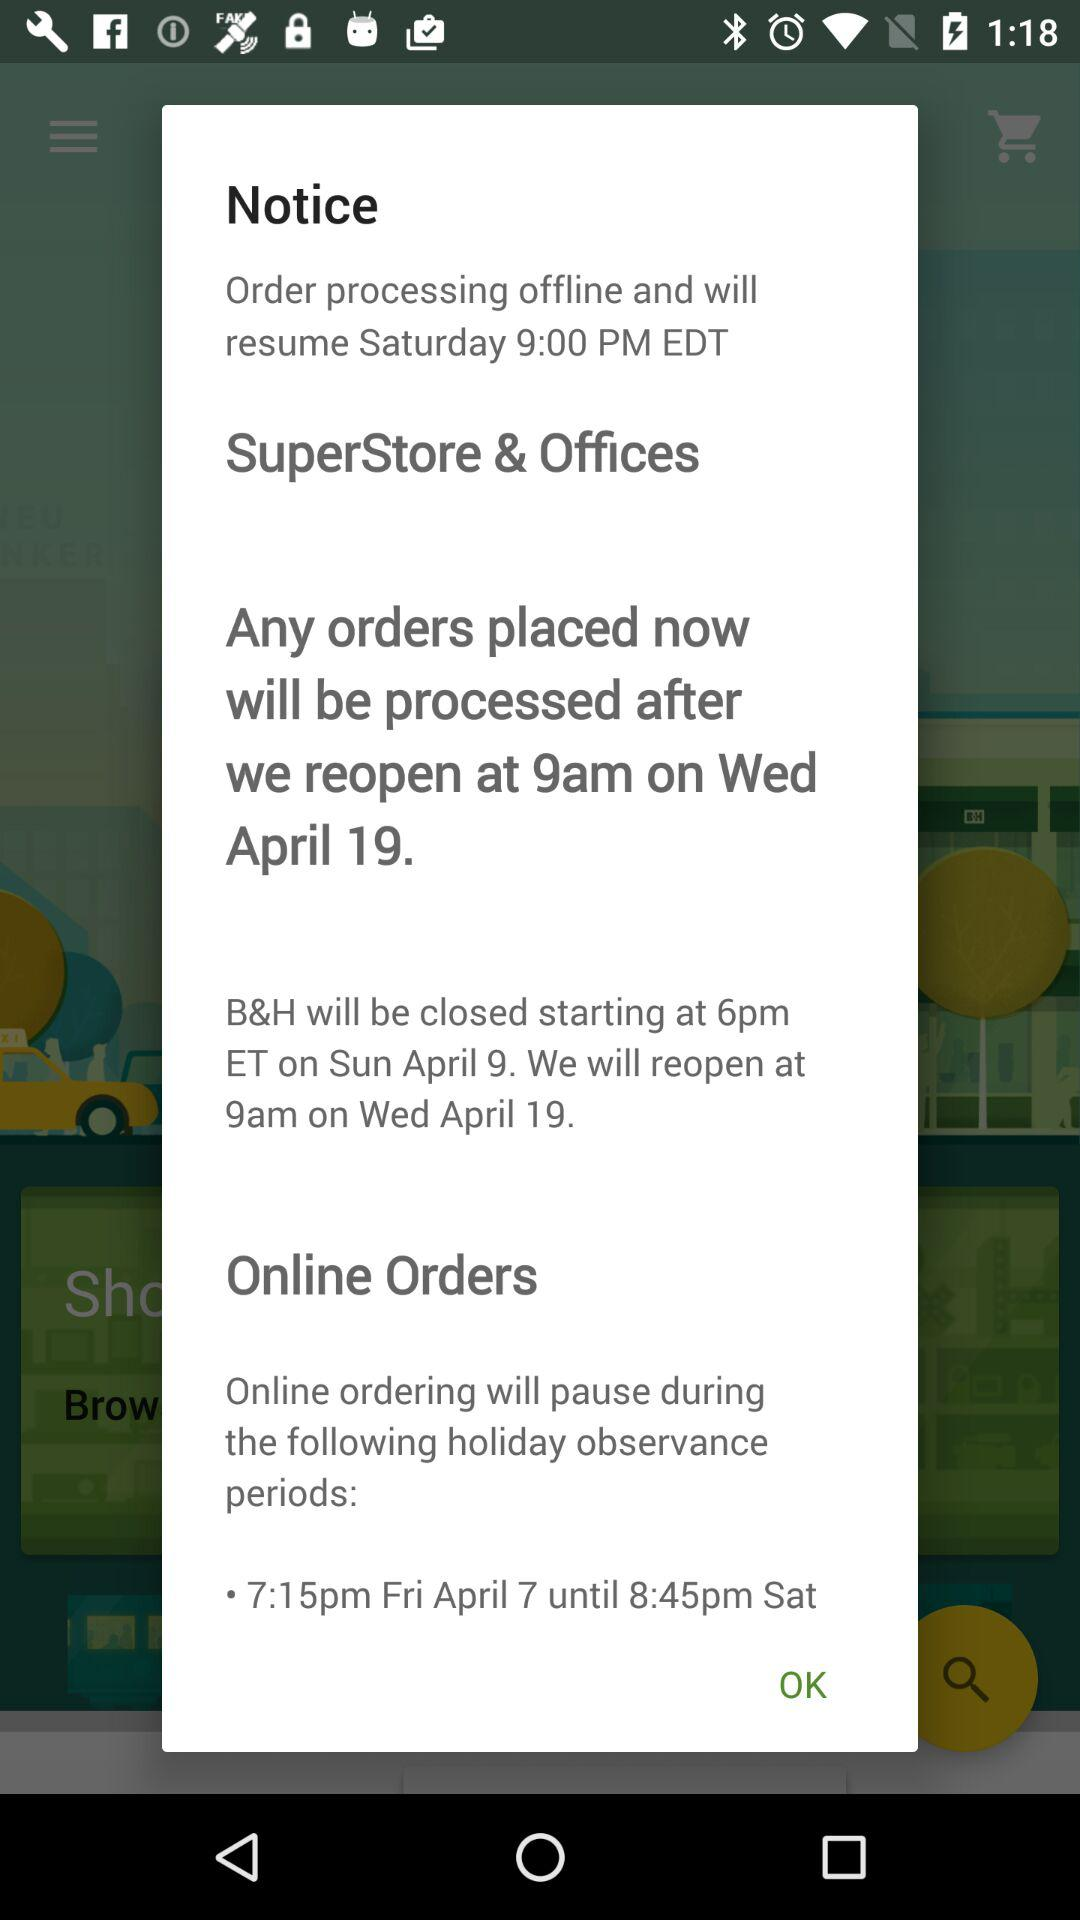What is the difference in time between when online ordering will pause and resume?
Answer the question using a single word or phrase. 1 hour 30 minutes 